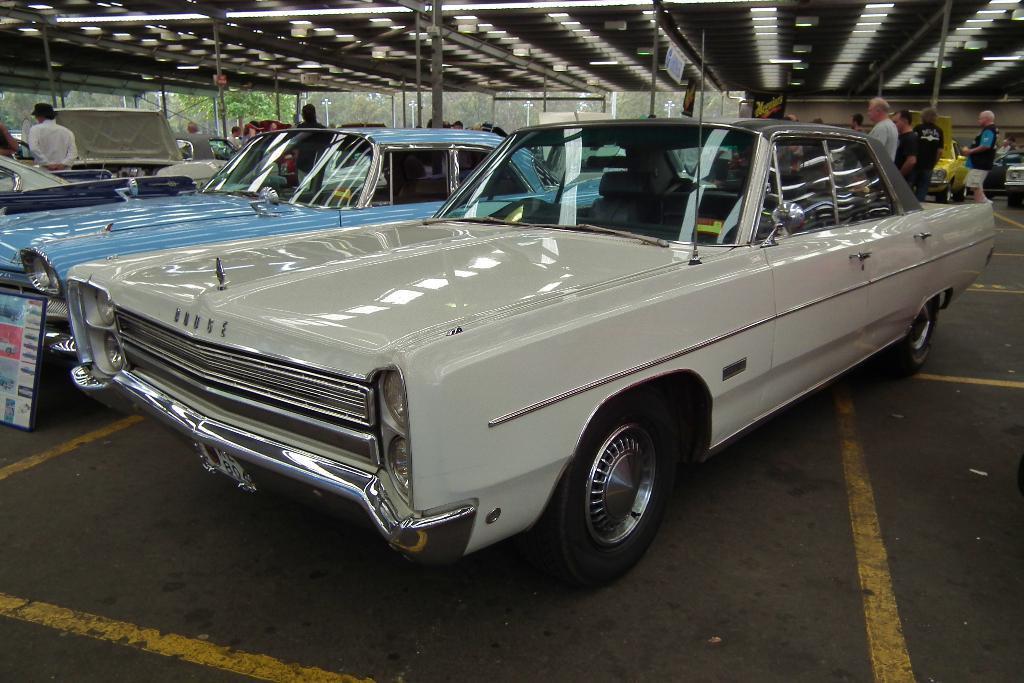How would you summarize this image in a sentence or two? In the center of the image, we can see cars on the road and in the background, there are some people and at the top, there is roof. 